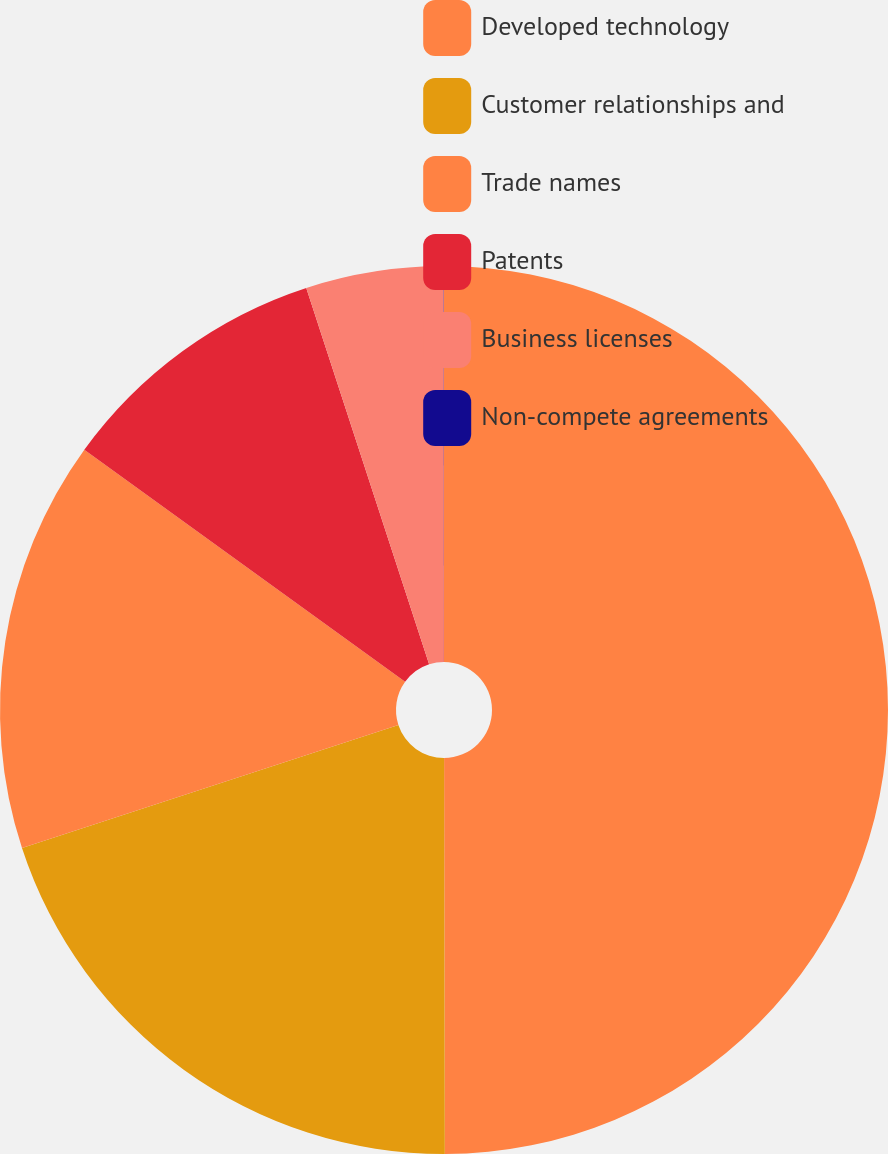<chart> <loc_0><loc_0><loc_500><loc_500><pie_chart><fcel>Developed technology<fcel>Customer relationships and<fcel>Trade names<fcel>Patents<fcel>Business licenses<fcel>Non-compete agreements<nl><fcel>49.97%<fcel>20.0%<fcel>15.0%<fcel>10.01%<fcel>5.01%<fcel>0.01%<nl></chart> 